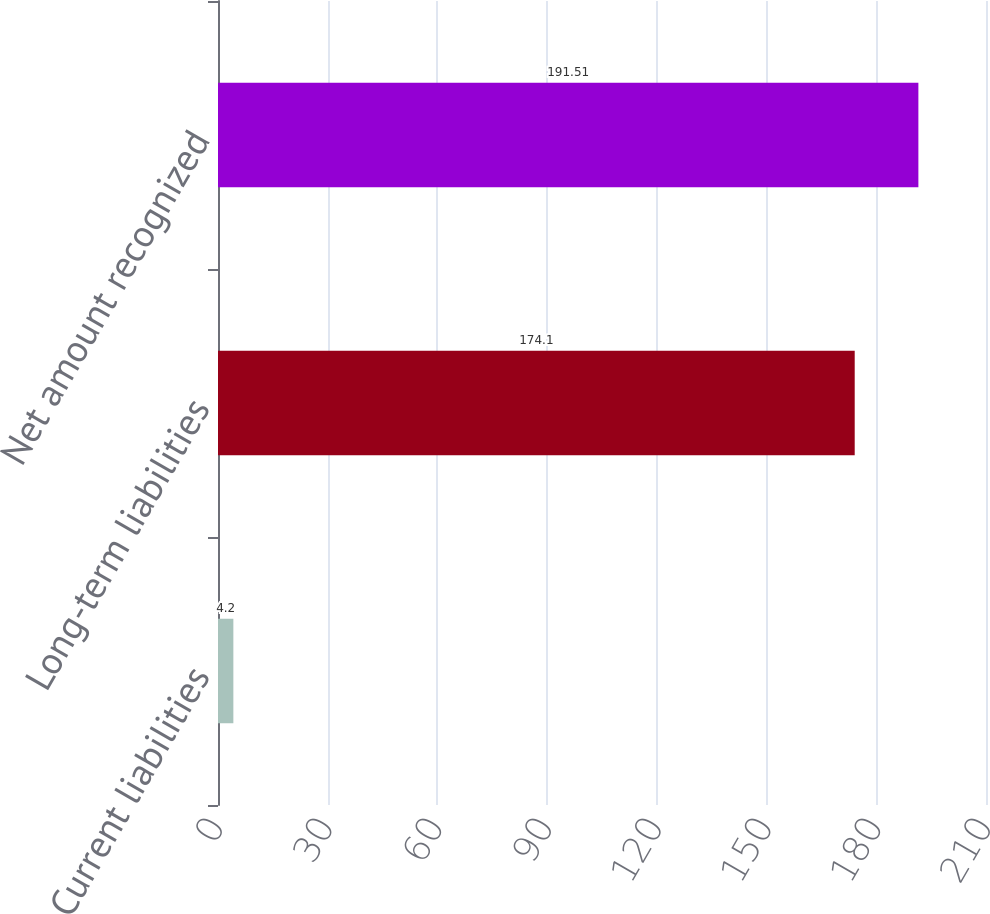<chart> <loc_0><loc_0><loc_500><loc_500><bar_chart><fcel>Current liabilities<fcel>Long-term liabilities<fcel>Net amount recognized<nl><fcel>4.2<fcel>174.1<fcel>191.51<nl></chart> 